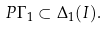<formula> <loc_0><loc_0><loc_500><loc_500>P \Gamma _ { 1 } \subset \Delta _ { 1 } ( I ) .</formula> 